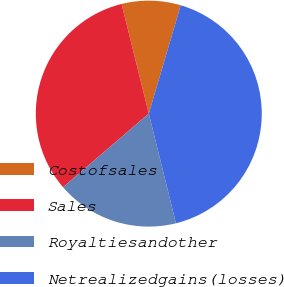Convert chart to OTSL. <chart><loc_0><loc_0><loc_500><loc_500><pie_chart><fcel>Costofsales<fcel>Sales<fcel>Royaltiesandother<fcel>Netrealizedgains(losses)<nl><fcel>8.43%<fcel>32.42%<fcel>17.58%<fcel>41.57%<nl></chart> 